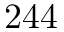<formula> <loc_0><loc_0><loc_500><loc_500>2 4 4</formula> 